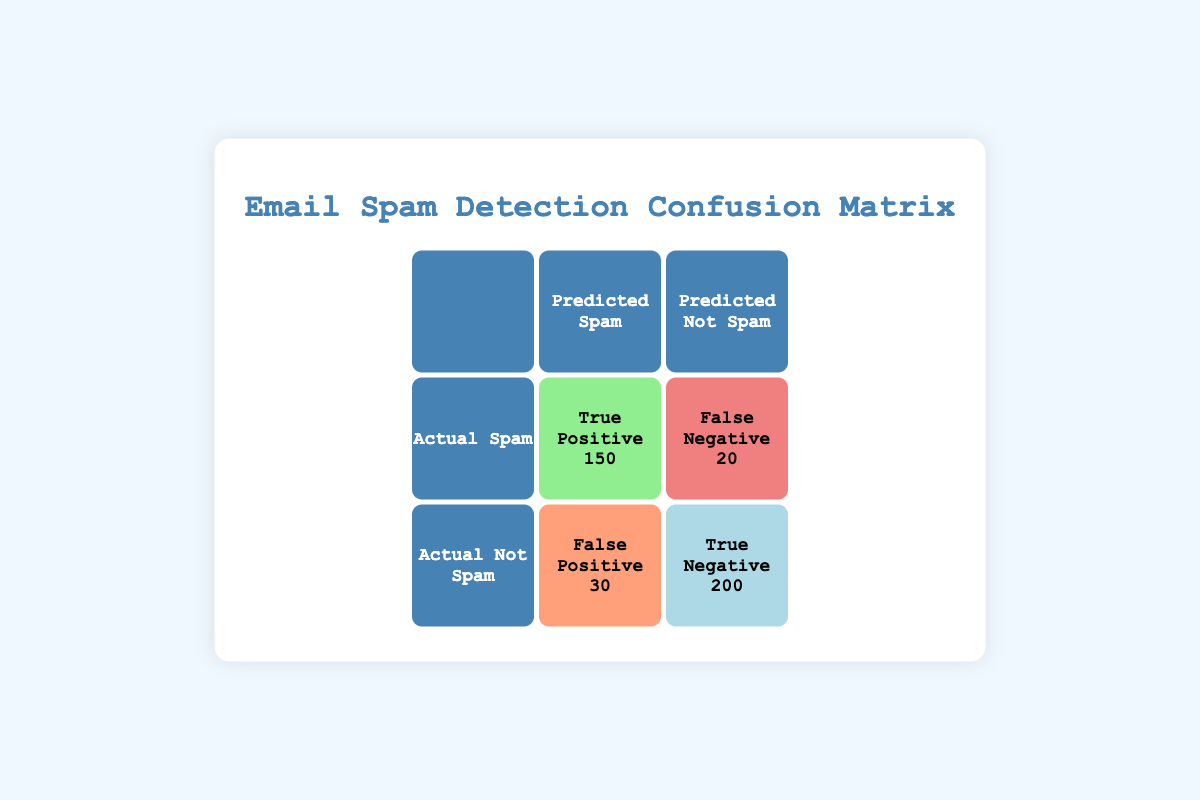What is the True Positive value in the confusion matrix? The True Positive value is provided in the table under the cell labeled "True Positive." It indicates the number of actual spam emails correctly predicted as spam. Looking at the table, the True Positive value is 150.
Answer: 150 How many emails were predicted as Not Spam incorrectly? The number of emails predicted as Not Spam incorrectly is given by the False Positive value. It can be found in the confusion matrix under the cell labeled "False Positive." The value is 30.
Answer: 30 What is the total number of actual Spam emails? To find the total number of actual Spam emails, we need to add the True Positive and False Negative values. The True Positive is 150, and the False Negative is 20. Therefore, the total is 150 + 20 = 170.
Answer: 170 Is the number of True Negatives greater than the number of False Positives? To check whether the True Negatives are greater than the False Positives, we compare the values directly from the table. The True Negative value is 200 and the False Positive value is 30. Since 200 is greater than 30, the statement is true.
Answer: Yes What is the total number of email samples tested for spam? The total number of email samples is the sum of all four values in the confusion matrix: True Positive (150) + True Negative (200) + False Positive (30) + False Negative (20). Calculating this gives us 150 + 200 + 30 + 20 = 400.
Answer: 400 What percentage of actual Spam emails were correctly identified as Spam? To find the percentage of actual Spam emails identified correctly, we use the True Positive value (150) divided by the total number of actual Spam emails (170). The calculation is (150 / 170) * 100, which equals approximately 88.24%.
Answer: 88.24% How many more emails were correctly predicted as Not Spam than incorrectly predicted as Spam? The value for correctly predicted Not Spam is found in the True Negative category (200). The value for incorrectly predicted Spam is found in the False Negative category (20). We subtract these values: 200 - 20 = 180.
Answer: 180 What is the average number of emails in each category (True Positive, True Negative, False Positive, False Negative)? To calculate the average, we sum all values in the confusion matrix: 150 (True Positive) + 200 (True Negative) + 30 (False Positive) + 20 (False Negative) = 400. Then, we divide by the number of categories (4), resulting in 400 / 4 = 100.
Answer: 100 